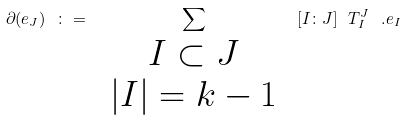<formula> <loc_0><loc_0><loc_500><loc_500>\partial ( e _ { J } ) \ \colon = \ \sum _ { \begin{array} { c } I \subset J \\ | I | = k - 1 \end{array} } \ [ I \colon J ] \ T ^ { J } _ { I } \ . e _ { I }</formula> 